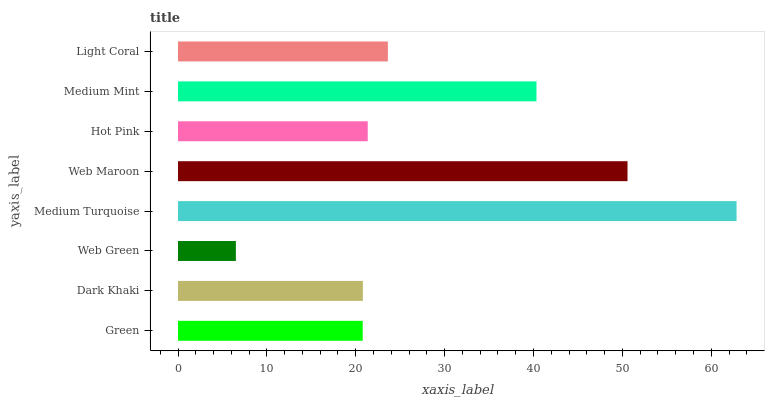Is Web Green the minimum?
Answer yes or no. Yes. Is Medium Turquoise the maximum?
Answer yes or no. Yes. Is Dark Khaki the minimum?
Answer yes or no. No. Is Dark Khaki the maximum?
Answer yes or no. No. Is Dark Khaki greater than Green?
Answer yes or no. Yes. Is Green less than Dark Khaki?
Answer yes or no. Yes. Is Green greater than Dark Khaki?
Answer yes or no. No. Is Dark Khaki less than Green?
Answer yes or no. No. Is Light Coral the high median?
Answer yes or no. Yes. Is Hot Pink the low median?
Answer yes or no. Yes. Is Green the high median?
Answer yes or no. No. Is Light Coral the low median?
Answer yes or no. No. 